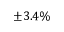<formula> <loc_0><loc_0><loc_500><loc_500>\pm 3 . 4 \%</formula> 